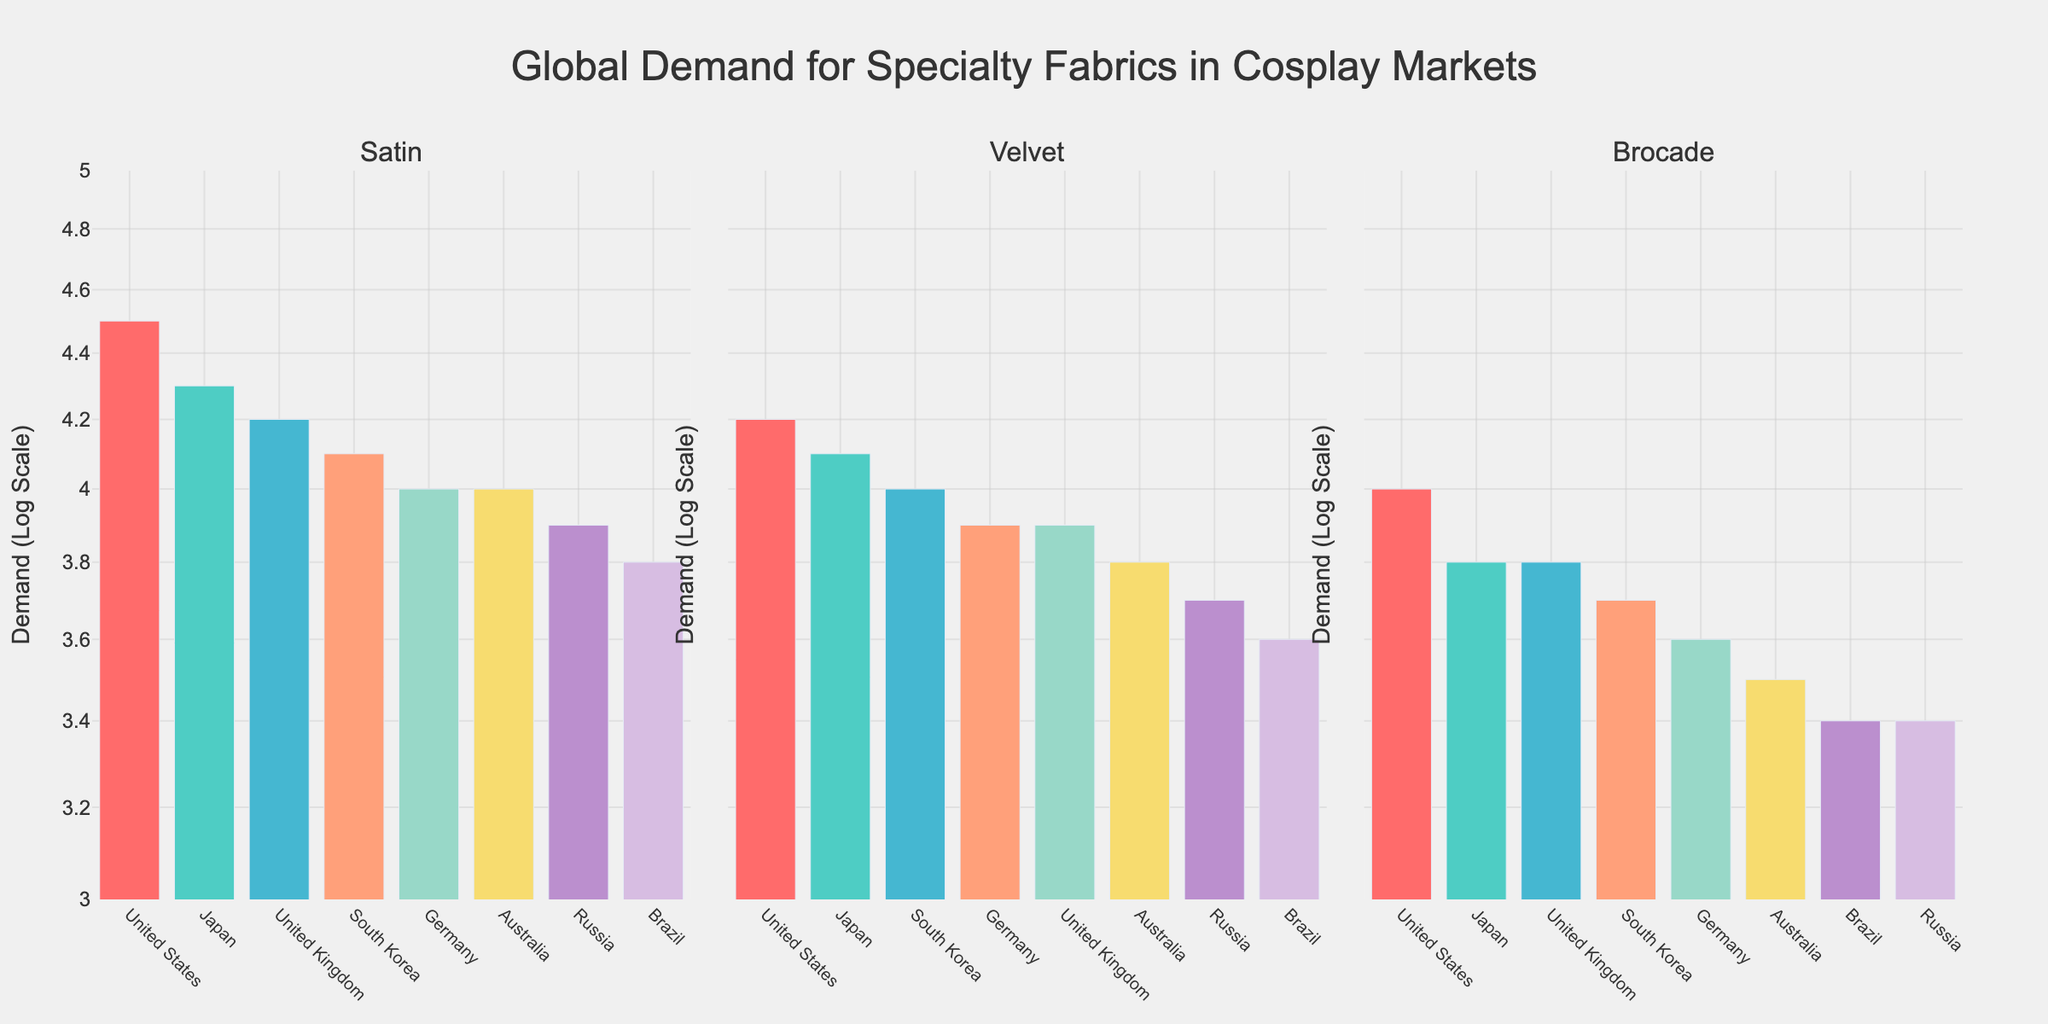How many countries are shown in the subplot for Velvet? To find the number of countries for Velvet, look at the x-axis labels under the Velvet subplot. Count the labels.
Answer: 8 In which subplot does the country with the highest demand appear, and what is the demand value? Check the y-axis values and bar heights for each subplot. The highest demand value is 4.5 in the Satin subplot for the United States.
Answer: Satin, 4.5 What is the combined log scale demand for Brocade from Japan and South Korea? Look for the bars representing Japan and South Korea in the Brocade subplot. Add their demand values: 3.8 (Japan) + 3.7 (South Korea) = 7.5.
Answer: 7.5 Which country shows the lowest log scale demand across all fabric types and what is its value? Check the lowest values in all three subplots. Brazil has the lowest value of 3.4 in both Velvet and Brocade subplots.
Answer: Brazil, 3.4 What is the difference in log scale demand for Satin between the United States and Brazil? Find the Satin demand values for the United States and Brazil in the Satin subplot. Subtract Brazil's value (3.8) from the U.S. value (4.5): 4.5 - 3.8 = 0.7.
Answer: 0.7 Compare the average log scale demand for Velvet across all countries. Which country has the closest value to this average? Calculate the average by summing up the Velvet demands and dividing by the number of countries: (4.2 + 4.1 + 4.0 + 3.9 + 3.9 + 3.6 + 3.8 + 3.7) / 8 = 3.9. The United Kingdom also has a demand value of 3.9.
Answer: United Kingdom Which two fabric types have the most similar log scale demand for Germany, and what is the difference? Check the log scale demands for Germany across all three fabric types: Satin (4.0), Velvet (3.9), Brocade (3.6). The values for Satin and Velvet are the closest, with a difference of 4.0 - 3.9 = 0.1.
Answer: Satin & Velvet, 0.1 What is the range of log scale demand values for Satin across the plotted countries? The highest value for Satin is 4.5 (United States), and the lowest is 3.8 (Brazil). The range is 4.5 - 3.8 = 0.7.
Answer: 0.7 Is there any country that shows the same log scale demand for two different fabric types? If yes, which country and what are the fabric types? Scan each subplot for demand values that are the same for any country. The United Kingdom has a demand of 3.9 for both Velvet and Brocade.
Answer: United Kingdom, Velvet & Brocade 